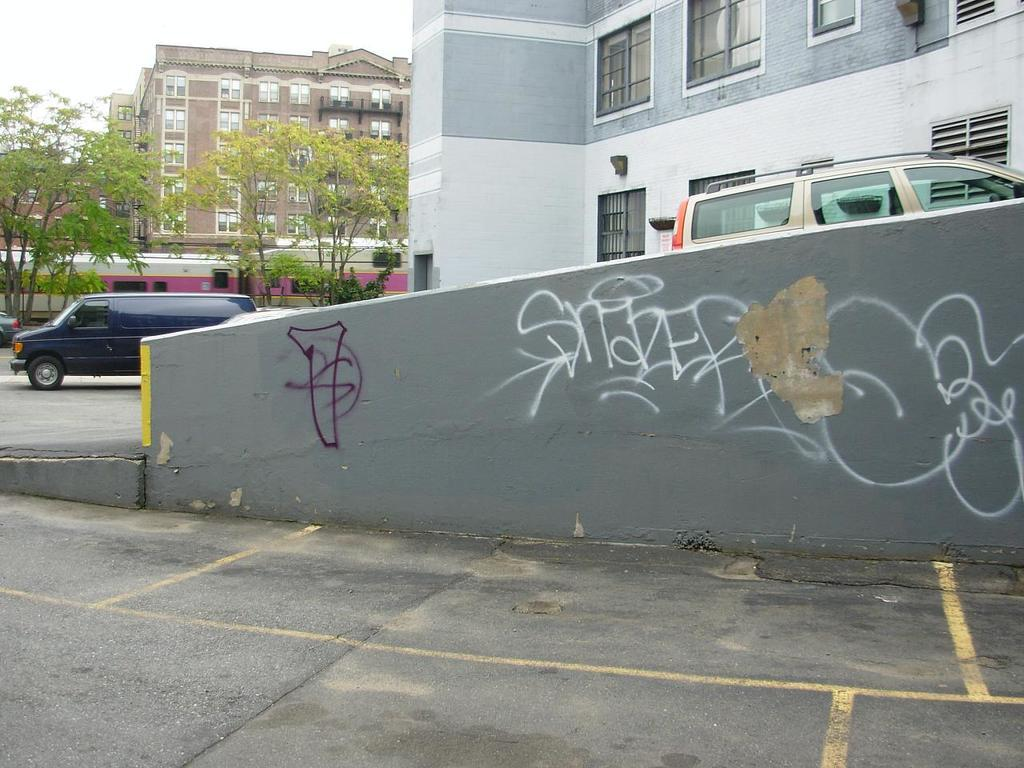What type of natural elements can be seen in the image? There are trees in the image. What type of man-made structures are present in the image? There are buildings in the image. What type of transportation is visible in the image? There are vehicles on the road in the image. Can you describe any text or writing in the image? There is a wall with writing in the image. What else can be seen on the ground in the image? There are other objects on the ground in the image. What is visible in the background of the image? The sky is visible in the background of the image. Can you see a railway track in the image? There is no railway track present in the image. What type of net can be seen catching the moon in the image? There is no net or moon present in the image. 